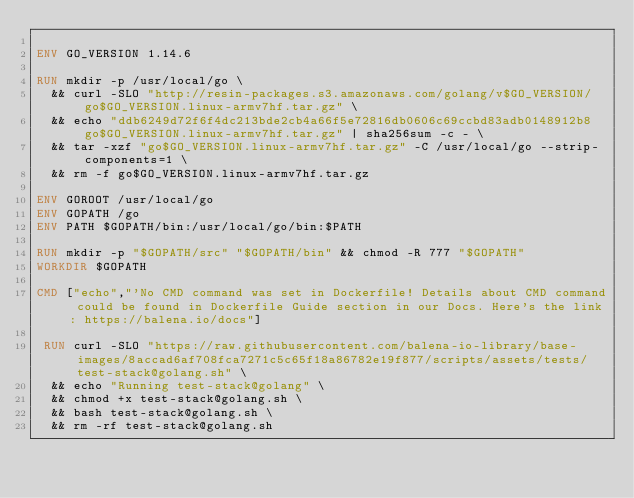<code> <loc_0><loc_0><loc_500><loc_500><_Dockerfile_>
ENV GO_VERSION 1.14.6

RUN mkdir -p /usr/local/go \
	&& curl -SLO "http://resin-packages.s3.amazonaws.com/golang/v$GO_VERSION/go$GO_VERSION.linux-armv7hf.tar.gz" \
	&& echo "ddb6249d72f6f4dc213bde2cb4a66f5e72816db0606c69ccbd83adb0148912b8  go$GO_VERSION.linux-armv7hf.tar.gz" | sha256sum -c - \
	&& tar -xzf "go$GO_VERSION.linux-armv7hf.tar.gz" -C /usr/local/go --strip-components=1 \
	&& rm -f go$GO_VERSION.linux-armv7hf.tar.gz

ENV GOROOT /usr/local/go
ENV GOPATH /go
ENV PATH $GOPATH/bin:/usr/local/go/bin:$PATH

RUN mkdir -p "$GOPATH/src" "$GOPATH/bin" && chmod -R 777 "$GOPATH"
WORKDIR $GOPATH

CMD ["echo","'No CMD command was set in Dockerfile! Details about CMD command could be found in Dockerfile Guide section in our Docs. Here's the link: https://balena.io/docs"]

 RUN curl -SLO "https://raw.githubusercontent.com/balena-io-library/base-images/8accad6af708fca7271c5c65f18a86782e19f877/scripts/assets/tests/test-stack@golang.sh" \
  && echo "Running test-stack@golang" \
  && chmod +x test-stack@golang.sh \
  && bash test-stack@golang.sh \
  && rm -rf test-stack@golang.sh 
</code> 